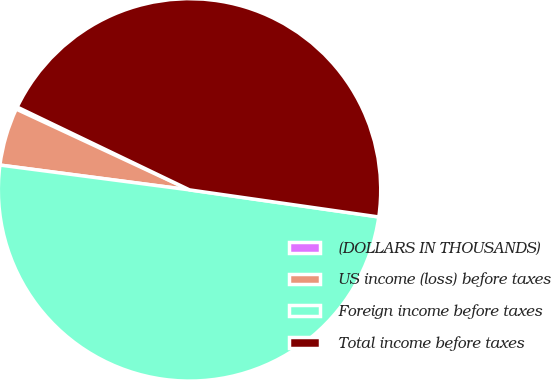Convert chart. <chart><loc_0><loc_0><loc_500><loc_500><pie_chart><fcel>(DOLLARS IN THOUSANDS)<fcel>US income (loss) before taxes<fcel>Foreign income before taxes<fcel>Total income before taxes<nl><fcel>0.19%<fcel>4.87%<fcel>49.81%<fcel>45.13%<nl></chart> 